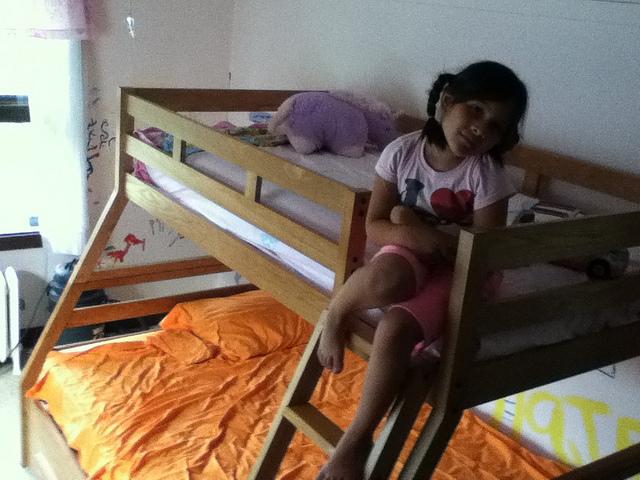Will this girl always fit well in this bed?
Be succinct. No. What is written on the girl's shirt?
Write a very short answer. I love. Will these people be sleeping in a stationary location?
Give a very brief answer. Yes. What do you call this kind of bed?
Keep it brief. Bunk bed. Do these beds fold up?
Be succinct. No. 